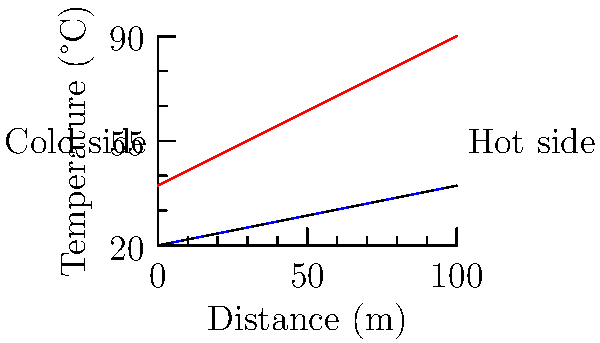In a geothermal system, the temperature gradient is represented by the graph above. The red line shows the temperature profile of the hot side, while the blue line represents the cold side. If the system is 100 meters long and the thermal conductivity of the ground is 2 W/(m·K), what is the total heat transfer rate through the system? To solve this problem, we'll follow these steps:

1. Identify the temperature difference:
   Hot side: $T_h = 40 + 0.5x$
   Cold side: $T_c = 20 + 0.2x$

2. Calculate the average temperature difference:
   $\Delta T_{avg} = (T_h - T_c)_{avg} = ((40 + 0.5x) - (20 + 0.2x))_{avg}$
   $\Delta T_{avg} = (20 + 0.3x)_{avg}$
   At x = 0: $\Delta T = 20$
   At x = 100: $\Delta T = 20 + 0.3(100) = 50$
   $\Delta T_{avg} = (20 + 50) / 2 = 35°C$

3. Use Fourier's Law of heat conduction:
   $q = -kA\frac{dT}{dx}$

   Where:
   $q$ = heat transfer rate (W)
   $k$ = thermal conductivity (W/(m·K))
   $A$ = cross-sectional area (m²)
   $\frac{dT}{dx}$ = temperature gradient (K/m)

4. Rearrange the equation for our system:
   $q = kA\frac{\Delta T_{avg}}{L}$

   Where:
   $L$ = length of the system (m)

5. Calculate the heat transfer rate:
   $q = 2 \cdot A \cdot \frac{35}{100}$
   $q = 0.7A$ W

The heat transfer rate depends on the cross-sectional area $A$, which is not given in the problem. Therefore, we express the final answer in terms of $A$.
Answer: $0.7A$ W, where $A$ is the cross-sectional area in m² 